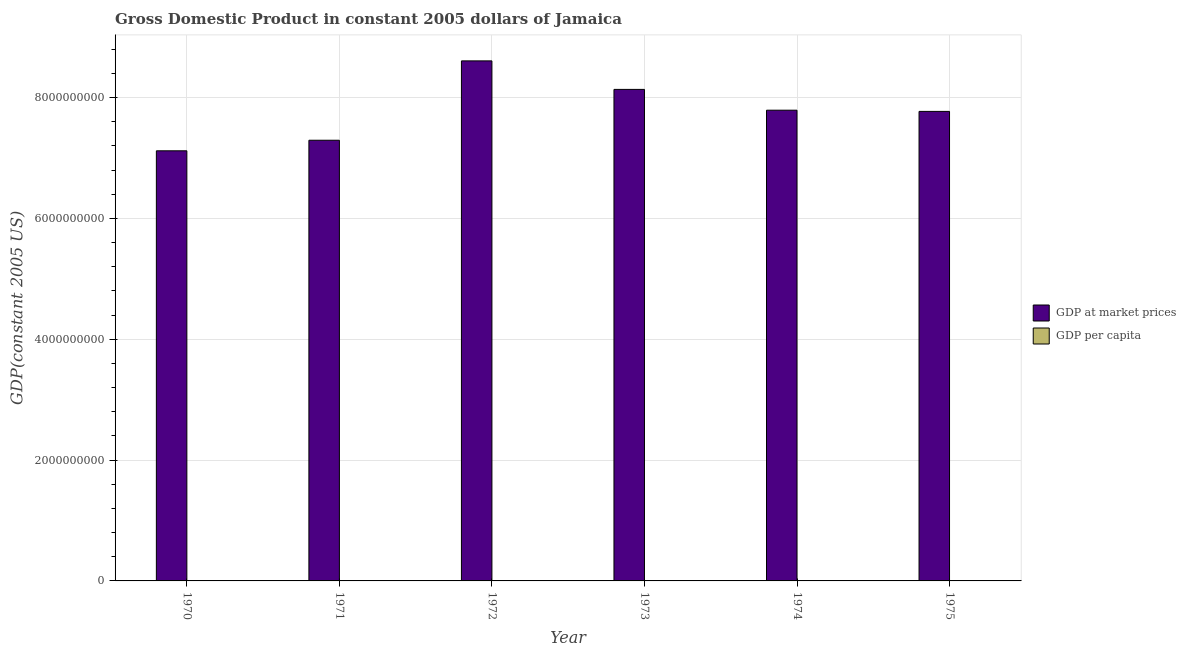Are the number of bars on each tick of the X-axis equal?
Keep it short and to the point. Yes. How many bars are there on the 3rd tick from the right?
Give a very brief answer. 2. What is the label of the 1st group of bars from the left?
Provide a short and direct response. 1970. In how many cases, is the number of bars for a given year not equal to the number of legend labels?
Offer a very short reply. 0. What is the gdp per capita in 1970?
Give a very brief answer. 3809.56. Across all years, what is the maximum gdp per capita?
Keep it short and to the point. 4471.74. Across all years, what is the minimum gdp at market prices?
Your response must be concise. 7.12e+09. In which year was the gdp per capita maximum?
Give a very brief answer. 1972. What is the total gdp at market prices in the graph?
Your response must be concise. 4.67e+1. What is the difference between the gdp per capita in 1972 and that in 1975?
Provide a short and direct response. 610.58. What is the difference between the gdp per capita in 1973 and the gdp at market prices in 1970?
Make the answer very short. 350.08. What is the average gdp per capita per year?
Give a very brief answer. 4012.41. In the year 1974, what is the difference between the gdp per capita and gdp at market prices?
Give a very brief answer. 0. What is the ratio of the gdp per capita in 1970 to that in 1971?
Give a very brief answer. 0.99. Is the difference between the gdp at market prices in 1972 and 1973 greater than the difference between the gdp per capita in 1972 and 1973?
Your answer should be very brief. No. What is the difference between the highest and the second highest gdp per capita?
Keep it short and to the point. 312.1. What is the difference between the highest and the lowest gdp per capita?
Provide a short and direct response. 662.18. In how many years, is the gdp at market prices greater than the average gdp at market prices taken over all years?
Your answer should be compact. 3. Is the sum of the gdp at market prices in 1970 and 1973 greater than the maximum gdp per capita across all years?
Keep it short and to the point. Yes. What does the 1st bar from the left in 1975 represents?
Provide a short and direct response. GDP at market prices. What does the 2nd bar from the right in 1975 represents?
Provide a succinct answer. GDP at market prices. What is the difference between two consecutive major ticks on the Y-axis?
Keep it short and to the point. 2.00e+09. What is the title of the graph?
Your answer should be very brief. Gross Domestic Product in constant 2005 dollars of Jamaica. What is the label or title of the Y-axis?
Your answer should be very brief. GDP(constant 2005 US). What is the GDP(constant 2005 US) in GDP at market prices in 1970?
Keep it short and to the point. 7.12e+09. What is the GDP(constant 2005 US) in GDP per capita in 1970?
Provide a short and direct response. 3809.56. What is the GDP(constant 2005 US) of GDP at market prices in 1971?
Your response must be concise. 7.30e+09. What is the GDP(constant 2005 US) in GDP per capita in 1971?
Make the answer very short. 3848.37. What is the GDP(constant 2005 US) of GDP at market prices in 1972?
Give a very brief answer. 8.61e+09. What is the GDP(constant 2005 US) of GDP per capita in 1972?
Your answer should be very brief. 4471.74. What is the GDP(constant 2005 US) in GDP at market prices in 1973?
Your answer should be very brief. 8.14e+09. What is the GDP(constant 2005 US) in GDP per capita in 1973?
Offer a terse response. 4159.63. What is the GDP(constant 2005 US) in GDP at market prices in 1974?
Ensure brevity in your answer.  7.79e+09. What is the GDP(constant 2005 US) in GDP per capita in 1974?
Provide a succinct answer. 3923.99. What is the GDP(constant 2005 US) of GDP at market prices in 1975?
Keep it short and to the point. 7.77e+09. What is the GDP(constant 2005 US) in GDP per capita in 1975?
Your answer should be compact. 3861.15. Across all years, what is the maximum GDP(constant 2005 US) in GDP at market prices?
Your answer should be very brief. 8.61e+09. Across all years, what is the maximum GDP(constant 2005 US) of GDP per capita?
Your response must be concise. 4471.74. Across all years, what is the minimum GDP(constant 2005 US) in GDP at market prices?
Keep it short and to the point. 7.12e+09. Across all years, what is the minimum GDP(constant 2005 US) in GDP per capita?
Provide a short and direct response. 3809.56. What is the total GDP(constant 2005 US) of GDP at market prices in the graph?
Your answer should be very brief. 4.67e+1. What is the total GDP(constant 2005 US) of GDP per capita in the graph?
Offer a terse response. 2.41e+04. What is the difference between the GDP(constant 2005 US) in GDP at market prices in 1970 and that in 1971?
Make the answer very short. -1.75e+08. What is the difference between the GDP(constant 2005 US) of GDP per capita in 1970 and that in 1971?
Your answer should be very brief. -38.81. What is the difference between the GDP(constant 2005 US) in GDP at market prices in 1970 and that in 1972?
Provide a succinct answer. -1.49e+09. What is the difference between the GDP(constant 2005 US) of GDP per capita in 1970 and that in 1972?
Offer a very short reply. -662.18. What is the difference between the GDP(constant 2005 US) of GDP at market prices in 1970 and that in 1973?
Make the answer very short. -1.02e+09. What is the difference between the GDP(constant 2005 US) of GDP per capita in 1970 and that in 1973?
Offer a terse response. -350.08. What is the difference between the GDP(constant 2005 US) in GDP at market prices in 1970 and that in 1974?
Ensure brevity in your answer.  -6.72e+08. What is the difference between the GDP(constant 2005 US) in GDP per capita in 1970 and that in 1974?
Your response must be concise. -114.43. What is the difference between the GDP(constant 2005 US) of GDP at market prices in 1970 and that in 1975?
Provide a short and direct response. -6.52e+08. What is the difference between the GDP(constant 2005 US) in GDP per capita in 1970 and that in 1975?
Keep it short and to the point. -51.6. What is the difference between the GDP(constant 2005 US) in GDP at market prices in 1971 and that in 1972?
Provide a short and direct response. -1.31e+09. What is the difference between the GDP(constant 2005 US) in GDP per capita in 1971 and that in 1972?
Offer a terse response. -623.37. What is the difference between the GDP(constant 2005 US) of GDP at market prices in 1971 and that in 1973?
Offer a terse response. -8.42e+08. What is the difference between the GDP(constant 2005 US) in GDP per capita in 1971 and that in 1973?
Your answer should be compact. -311.27. What is the difference between the GDP(constant 2005 US) of GDP at market prices in 1971 and that in 1974?
Your answer should be very brief. -4.97e+08. What is the difference between the GDP(constant 2005 US) of GDP per capita in 1971 and that in 1974?
Offer a very short reply. -75.62. What is the difference between the GDP(constant 2005 US) of GDP at market prices in 1971 and that in 1975?
Make the answer very short. -4.77e+08. What is the difference between the GDP(constant 2005 US) in GDP per capita in 1971 and that in 1975?
Provide a succinct answer. -12.79. What is the difference between the GDP(constant 2005 US) of GDP at market prices in 1972 and that in 1973?
Provide a short and direct response. 4.72e+08. What is the difference between the GDP(constant 2005 US) of GDP per capita in 1972 and that in 1973?
Your response must be concise. 312.1. What is the difference between the GDP(constant 2005 US) of GDP at market prices in 1972 and that in 1974?
Your response must be concise. 8.16e+08. What is the difference between the GDP(constant 2005 US) of GDP per capita in 1972 and that in 1974?
Your response must be concise. 547.75. What is the difference between the GDP(constant 2005 US) of GDP at market prices in 1972 and that in 1975?
Keep it short and to the point. 8.36e+08. What is the difference between the GDP(constant 2005 US) of GDP per capita in 1972 and that in 1975?
Your response must be concise. 610.58. What is the difference between the GDP(constant 2005 US) of GDP at market prices in 1973 and that in 1974?
Provide a short and direct response. 3.44e+08. What is the difference between the GDP(constant 2005 US) of GDP per capita in 1973 and that in 1974?
Ensure brevity in your answer.  235.65. What is the difference between the GDP(constant 2005 US) of GDP at market prices in 1973 and that in 1975?
Give a very brief answer. 3.64e+08. What is the difference between the GDP(constant 2005 US) in GDP per capita in 1973 and that in 1975?
Offer a terse response. 298.48. What is the difference between the GDP(constant 2005 US) of GDP at market prices in 1974 and that in 1975?
Provide a short and direct response. 2.00e+07. What is the difference between the GDP(constant 2005 US) of GDP per capita in 1974 and that in 1975?
Ensure brevity in your answer.  62.83. What is the difference between the GDP(constant 2005 US) in GDP at market prices in 1970 and the GDP(constant 2005 US) in GDP per capita in 1971?
Offer a very short reply. 7.12e+09. What is the difference between the GDP(constant 2005 US) in GDP at market prices in 1970 and the GDP(constant 2005 US) in GDP per capita in 1972?
Provide a short and direct response. 7.12e+09. What is the difference between the GDP(constant 2005 US) in GDP at market prices in 1970 and the GDP(constant 2005 US) in GDP per capita in 1973?
Keep it short and to the point. 7.12e+09. What is the difference between the GDP(constant 2005 US) in GDP at market prices in 1970 and the GDP(constant 2005 US) in GDP per capita in 1974?
Your answer should be compact. 7.12e+09. What is the difference between the GDP(constant 2005 US) of GDP at market prices in 1970 and the GDP(constant 2005 US) of GDP per capita in 1975?
Offer a terse response. 7.12e+09. What is the difference between the GDP(constant 2005 US) in GDP at market prices in 1971 and the GDP(constant 2005 US) in GDP per capita in 1972?
Give a very brief answer. 7.30e+09. What is the difference between the GDP(constant 2005 US) in GDP at market prices in 1971 and the GDP(constant 2005 US) in GDP per capita in 1973?
Keep it short and to the point. 7.30e+09. What is the difference between the GDP(constant 2005 US) in GDP at market prices in 1971 and the GDP(constant 2005 US) in GDP per capita in 1974?
Your response must be concise. 7.30e+09. What is the difference between the GDP(constant 2005 US) in GDP at market prices in 1971 and the GDP(constant 2005 US) in GDP per capita in 1975?
Provide a short and direct response. 7.30e+09. What is the difference between the GDP(constant 2005 US) in GDP at market prices in 1972 and the GDP(constant 2005 US) in GDP per capita in 1973?
Ensure brevity in your answer.  8.61e+09. What is the difference between the GDP(constant 2005 US) in GDP at market prices in 1972 and the GDP(constant 2005 US) in GDP per capita in 1974?
Ensure brevity in your answer.  8.61e+09. What is the difference between the GDP(constant 2005 US) in GDP at market prices in 1972 and the GDP(constant 2005 US) in GDP per capita in 1975?
Provide a short and direct response. 8.61e+09. What is the difference between the GDP(constant 2005 US) of GDP at market prices in 1973 and the GDP(constant 2005 US) of GDP per capita in 1974?
Your response must be concise. 8.14e+09. What is the difference between the GDP(constant 2005 US) in GDP at market prices in 1973 and the GDP(constant 2005 US) in GDP per capita in 1975?
Ensure brevity in your answer.  8.14e+09. What is the difference between the GDP(constant 2005 US) in GDP at market prices in 1974 and the GDP(constant 2005 US) in GDP per capita in 1975?
Your answer should be compact. 7.79e+09. What is the average GDP(constant 2005 US) in GDP at market prices per year?
Offer a terse response. 7.79e+09. What is the average GDP(constant 2005 US) in GDP per capita per year?
Ensure brevity in your answer.  4012.41. In the year 1970, what is the difference between the GDP(constant 2005 US) of GDP at market prices and GDP(constant 2005 US) of GDP per capita?
Keep it short and to the point. 7.12e+09. In the year 1971, what is the difference between the GDP(constant 2005 US) of GDP at market prices and GDP(constant 2005 US) of GDP per capita?
Your answer should be compact. 7.30e+09. In the year 1972, what is the difference between the GDP(constant 2005 US) in GDP at market prices and GDP(constant 2005 US) in GDP per capita?
Provide a short and direct response. 8.61e+09. In the year 1973, what is the difference between the GDP(constant 2005 US) in GDP at market prices and GDP(constant 2005 US) in GDP per capita?
Ensure brevity in your answer.  8.14e+09. In the year 1974, what is the difference between the GDP(constant 2005 US) in GDP at market prices and GDP(constant 2005 US) in GDP per capita?
Keep it short and to the point. 7.79e+09. In the year 1975, what is the difference between the GDP(constant 2005 US) in GDP at market prices and GDP(constant 2005 US) in GDP per capita?
Offer a terse response. 7.77e+09. What is the ratio of the GDP(constant 2005 US) of GDP at market prices in 1970 to that in 1972?
Provide a short and direct response. 0.83. What is the ratio of the GDP(constant 2005 US) of GDP per capita in 1970 to that in 1972?
Provide a short and direct response. 0.85. What is the ratio of the GDP(constant 2005 US) of GDP at market prices in 1970 to that in 1973?
Provide a succinct answer. 0.88. What is the ratio of the GDP(constant 2005 US) in GDP per capita in 1970 to that in 1973?
Offer a terse response. 0.92. What is the ratio of the GDP(constant 2005 US) in GDP at market prices in 1970 to that in 1974?
Offer a very short reply. 0.91. What is the ratio of the GDP(constant 2005 US) in GDP per capita in 1970 to that in 1974?
Your answer should be very brief. 0.97. What is the ratio of the GDP(constant 2005 US) of GDP at market prices in 1970 to that in 1975?
Your answer should be very brief. 0.92. What is the ratio of the GDP(constant 2005 US) of GDP per capita in 1970 to that in 1975?
Ensure brevity in your answer.  0.99. What is the ratio of the GDP(constant 2005 US) in GDP at market prices in 1971 to that in 1972?
Give a very brief answer. 0.85. What is the ratio of the GDP(constant 2005 US) in GDP per capita in 1971 to that in 1972?
Your answer should be compact. 0.86. What is the ratio of the GDP(constant 2005 US) in GDP at market prices in 1971 to that in 1973?
Your answer should be compact. 0.9. What is the ratio of the GDP(constant 2005 US) in GDP per capita in 1971 to that in 1973?
Your answer should be very brief. 0.93. What is the ratio of the GDP(constant 2005 US) in GDP at market prices in 1971 to that in 1974?
Provide a short and direct response. 0.94. What is the ratio of the GDP(constant 2005 US) of GDP per capita in 1971 to that in 1974?
Your response must be concise. 0.98. What is the ratio of the GDP(constant 2005 US) of GDP at market prices in 1971 to that in 1975?
Give a very brief answer. 0.94. What is the ratio of the GDP(constant 2005 US) in GDP per capita in 1971 to that in 1975?
Your response must be concise. 1. What is the ratio of the GDP(constant 2005 US) of GDP at market prices in 1972 to that in 1973?
Offer a terse response. 1.06. What is the ratio of the GDP(constant 2005 US) in GDP per capita in 1972 to that in 1973?
Offer a very short reply. 1.07. What is the ratio of the GDP(constant 2005 US) of GDP at market prices in 1972 to that in 1974?
Provide a succinct answer. 1.1. What is the ratio of the GDP(constant 2005 US) of GDP per capita in 1972 to that in 1974?
Your response must be concise. 1.14. What is the ratio of the GDP(constant 2005 US) in GDP at market prices in 1972 to that in 1975?
Your response must be concise. 1.11. What is the ratio of the GDP(constant 2005 US) in GDP per capita in 1972 to that in 1975?
Make the answer very short. 1.16. What is the ratio of the GDP(constant 2005 US) of GDP at market prices in 1973 to that in 1974?
Make the answer very short. 1.04. What is the ratio of the GDP(constant 2005 US) of GDP per capita in 1973 to that in 1974?
Offer a very short reply. 1.06. What is the ratio of the GDP(constant 2005 US) of GDP at market prices in 1973 to that in 1975?
Keep it short and to the point. 1.05. What is the ratio of the GDP(constant 2005 US) of GDP per capita in 1973 to that in 1975?
Offer a very short reply. 1.08. What is the ratio of the GDP(constant 2005 US) of GDP per capita in 1974 to that in 1975?
Make the answer very short. 1.02. What is the difference between the highest and the second highest GDP(constant 2005 US) in GDP at market prices?
Offer a terse response. 4.72e+08. What is the difference between the highest and the second highest GDP(constant 2005 US) in GDP per capita?
Ensure brevity in your answer.  312.1. What is the difference between the highest and the lowest GDP(constant 2005 US) of GDP at market prices?
Your response must be concise. 1.49e+09. What is the difference between the highest and the lowest GDP(constant 2005 US) of GDP per capita?
Provide a succinct answer. 662.18. 